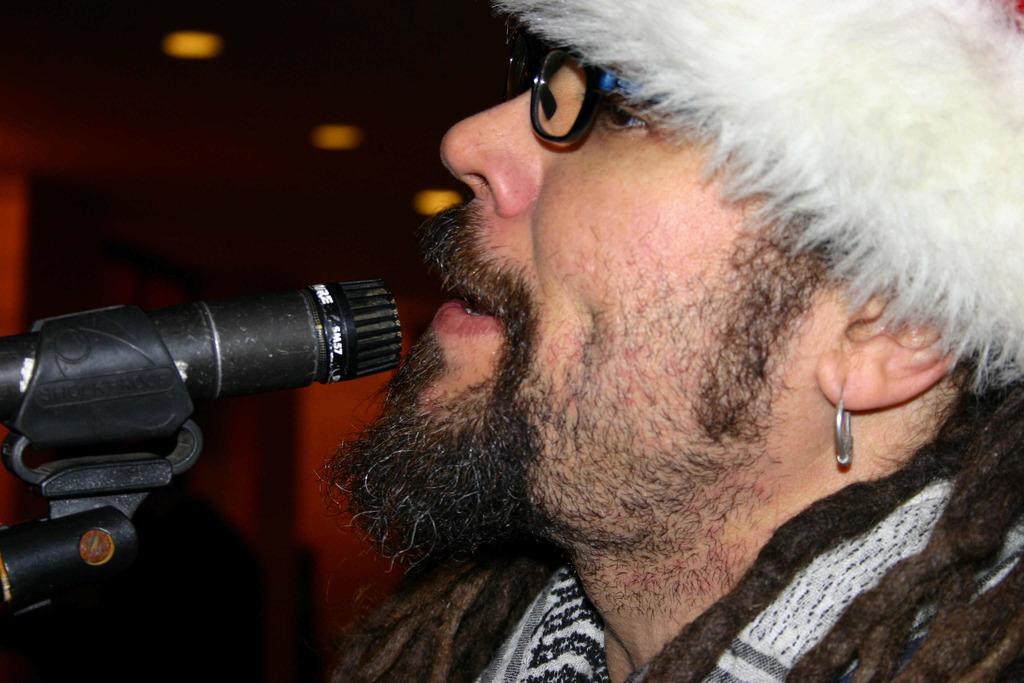Please provide a concise description of this image. As we can see in the image there is a man wearing spectacles and in front of him there is a mic. The background is little dark. 